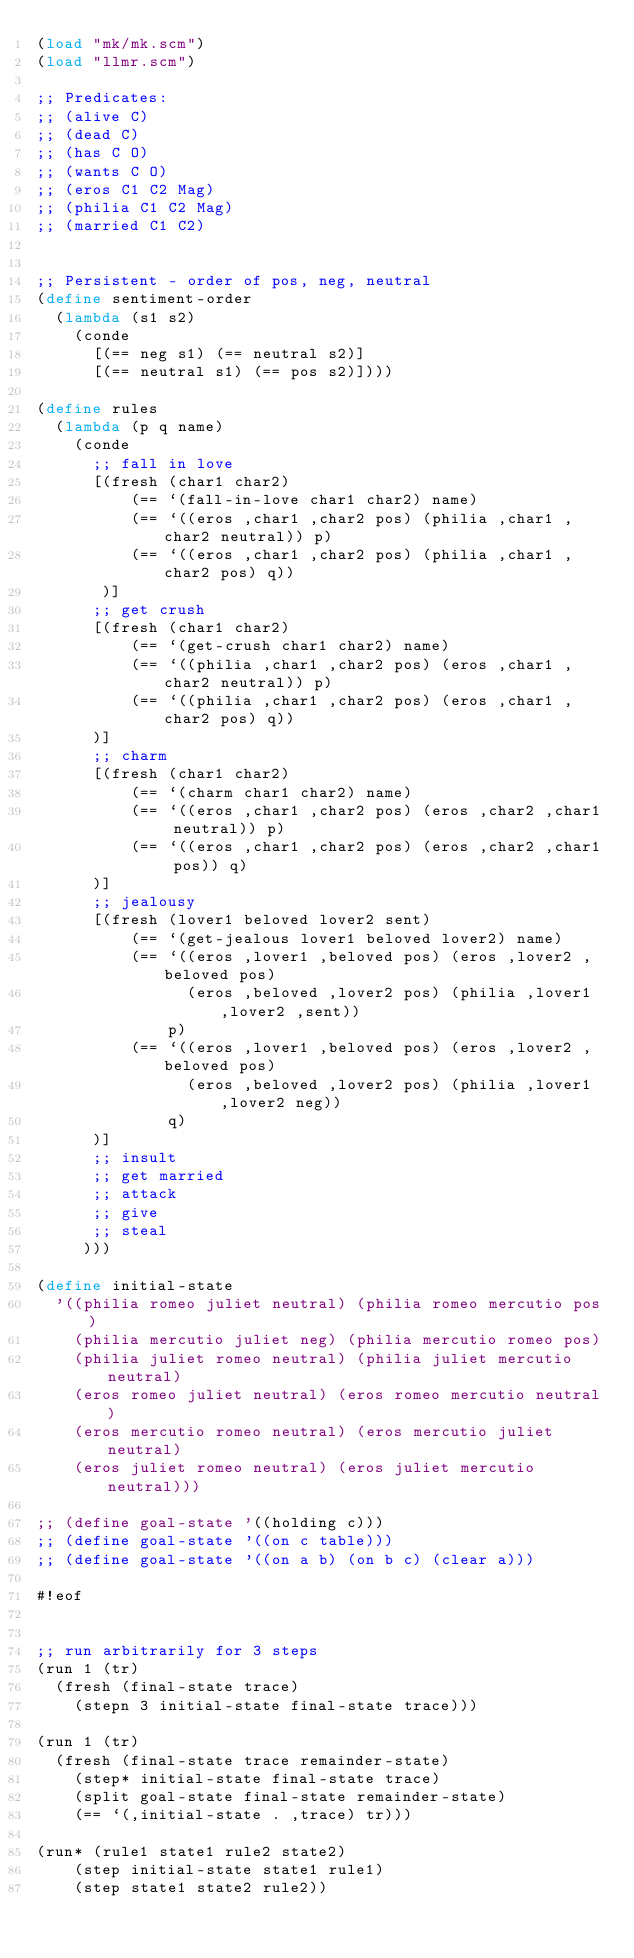<code> <loc_0><loc_0><loc_500><loc_500><_Scheme_>(load "mk/mk.scm")
(load "llmr.scm")

;; Predicates:
;; (alive C)
;; (dead C)
;; (has C O)
;; (wants C O)
;; (eros C1 C2 Mag)
;; (philia C1 C2 Mag)
;; (married C1 C2)


;; Persistent - order of pos, neg, neutral
(define sentiment-order
  (lambda (s1 s2)
    (conde
      [(== neg s1) (== neutral s2)]
      [(== neutral s1) (== pos s2)])))

(define rules
  (lambda (p q name)
    (conde
      ;; fall in love
      [(fresh (char1 char2)
          (== `(fall-in-love char1 char2) name)
          (== `((eros ,char1 ,char2 pos) (philia ,char1 ,char2 neutral)) p)
          (== `((eros ,char1 ,char2 pos) (philia ,char1 ,char2 pos) q))
       )]
      ;; get crush
      [(fresh (char1 char2)
          (== `(get-crush char1 char2) name)
          (== `((philia ,char1 ,char2 pos) (eros ,char1 ,char2 neutral)) p)
          (== `((philia ,char1 ,char2 pos) (eros ,char1 ,char2 pos) q))
      )]
      ;; charm
      [(fresh (char1 char2)
          (== `(charm char1 char2) name)
          (== `((eros ,char1 ,char2 pos) (eros ,char2 ,char1 neutral)) p)
          (== `((eros ,char1 ,char2 pos) (eros ,char2 ,char1 pos)) q)
      )]
      ;; jealousy
      [(fresh (lover1 beloved lover2 sent)
          (== `(get-jealous lover1 beloved lover2) name)
          (== `((eros ,lover1 ,beloved pos) (eros ,lover2 ,beloved pos)
                (eros ,beloved ,lover2 pos) (philia ,lover1 ,lover2 ,sent))
              p)
          (== `((eros ,lover1 ,beloved pos) (eros ,lover2 ,beloved pos)
                (eros ,beloved ,lover2 pos) (philia ,lover1 ,lover2 neg)) 
              q)
      )]
      ;; insult
      ;; get married
      ;; attack
      ;; give
      ;; steal
     )))

(define initial-state 
  '((philia romeo juliet neutral) (philia romeo mercutio pos)
    (philia mercutio juliet neg) (philia mercutio romeo pos)
    (philia juliet romeo neutral) (philia juliet mercutio neutral)
    (eros romeo juliet neutral) (eros romeo mercutio neutral)
    (eros mercutio romeo neutral) (eros mercutio juliet neutral)
    (eros juliet romeo neutral) (eros juliet mercutio neutral)))

;; (define goal-state '((holding c)))
;; (define goal-state '((on c table)))
;; (define goal-state '((on a b) (on b c) (clear a)))

#!eof


;; run arbitrarily for 3 steps
(run 1 (tr)
  (fresh (final-state trace)
    (stepn 3 initial-state final-state trace)))

(run 1 (tr)
  (fresh (final-state trace remainder-state)
    (step* initial-state final-state trace)
    (split goal-state final-state remainder-state)
    (== `(,initial-state . ,trace) tr)))

(run* (rule1 state1 rule2 state2)
    (step initial-state state1 rule1)
    (step state1 state2 rule2))
</code> 